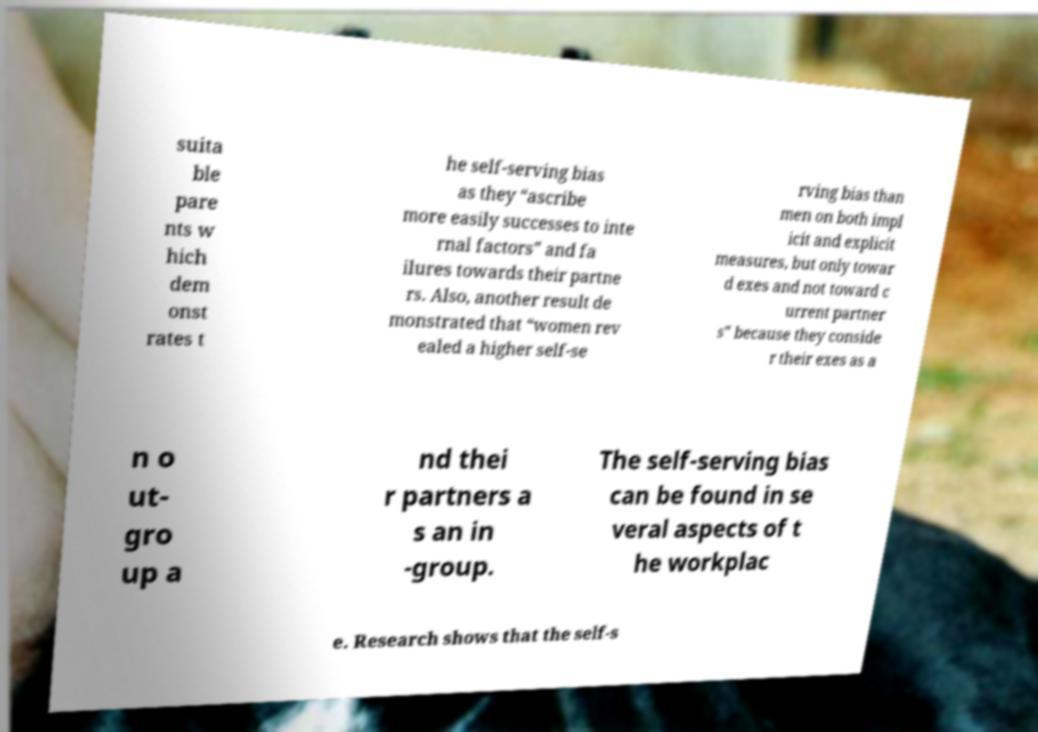Could you extract and type out the text from this image? suita ble pare nts w hich dem onst rates t he self-serving bias as they “ascribe more easily successes to inte rnal factors” and fa ilures towards their partne rs. Also, another result de monstrated that “women rev ealed a higher self-se rving bias than men on both impl icit and explicit measures, but only towar d exes and not toward c urrent partner s” because they conside r their exes as a n o ut- gro up a nd thei r partners a s an in -group. The self-serving bias can be found in se veral aspects of t he workplac e. Research shows that the self-s 